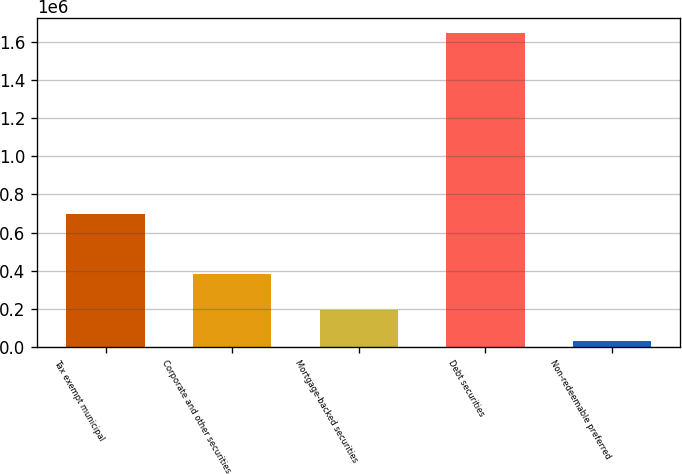<chart> <loc_0><loc_0><loc_500><loc_500><bar_chart><fcel>Tax exempt municipal<fcel>Corporate and other securities<fcel>Mortgage-backed securities<fcel>Debt securities<fcel>Non-redeemable preferred<nl><fcel>698842<fcel>379810<fcel>192930<fcel>1.64506e+06<fcel>31582<nl></chart> 